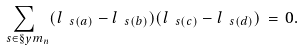Convert formula to latex. <formula><loc_0><loc_0><loc_500><loc_500>\sum _ { \ s \in \S y m _ { n } } ( l _ { \ s ( a ) } - l _ { \ s ( b ) } ) ( l _ { \ s ( c ) } - l _ { \ s ( d ) } ) \, = \, 0 .</formula> 